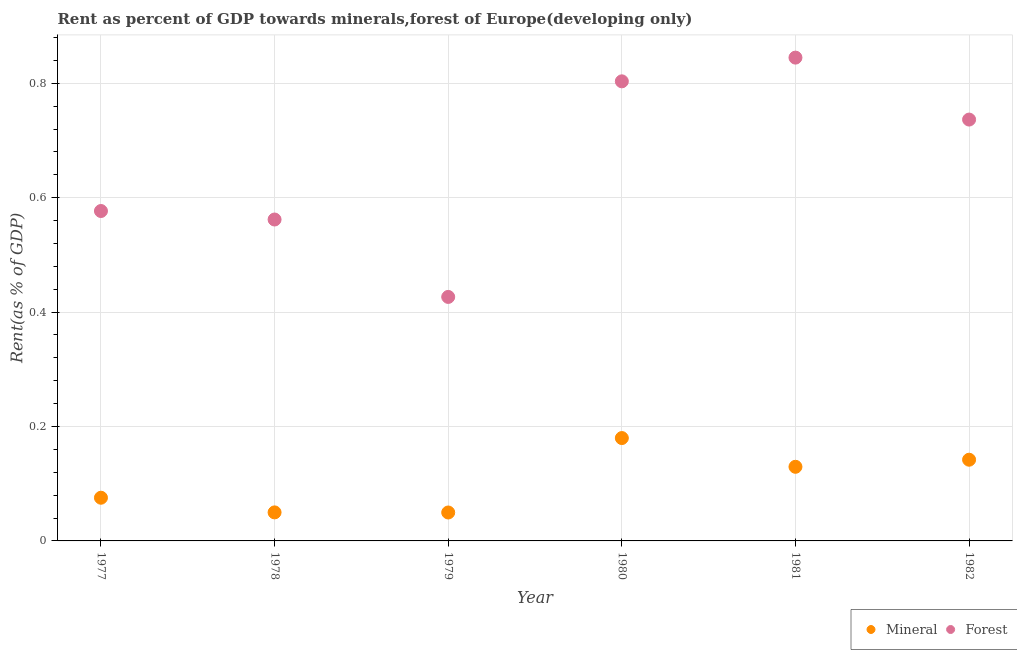What is the mineral rent in 1979?
Ensure brevity in your answer.  0.05. Across all years, what is the maximum forest rent?
Your answer should be very brief. 0.84. Across all years, what is the minimum forest rent?
Your answer should be compact. 0.43. In which year was the mineral rent maximum?
Offer a very short reply. 1980. In which year was the forest rent minimum?
Provide a succinct answer. 1979. What is the total forest rent in the graph?
Offer a very short reply. 3.95. What is the difference between the mineral rent in 1981 and that in 1982?
Your answer should be compact. -0.01. What is the difference between the forest rent in 1981 and the mineral rent in 1978?
Give a very brief answer. 0.79. What is the average mineral rent per year?
Your answer should be compact. 0.1. In the year 1980, what is the difference between the forest rent and mineral rent?
Provide a short and direct response. 0.62. What is the ratio of the mineral rent in 1977 to that in 1980?
Your response must be concise. 0.42. Is the difference between the mineral rent in 1977 and 1978 greater than the difference between the forest rent in 1977 and 1978?
Give a very brief answer. Yes. What is the difference between the highest and the second highest forest rent?
Give a very brief answer. 0.04. What is the difference between the highest and the lowest forest rent?
Provide a short and direct response. 0.42. Does the forest rent monotonically increase over the years?
Make the answer very short. No. Is the forest rent strictly greater than the mineral rent over the years?
Your answer should be compact. Yes. Is the forest rent strictly less than the mineral rent over the years?
Provide a succinct answer. No. How many dotlines are there?
Your answer should be very brief. 2. Does the graph contain any zero values?
Offer a very short reply. No. What is the title of the graph?
Ensure brevity in your answer.  Rent as percent of GDP towards minerals,forest of Europe(developing only). What is the label or title of the X-axis?
Ensure brevity in your answer.  Year. What is the label or title of the Y-axis?
Your answer should be very brief. Rent(as % of GDP). What is the Rent(as % of GDP) of Mineral in 1977?
Your response must be concise. 0.08. What is the Rent(as % of GDP) of Forest in 1977?
Your response must be concise. 0.58. What is the Rent(as % of GDP) of Mineral in 1978?
Your answer should be compact. 0.05. What is the Rent(as % of GDP) in Forest in 1978?
Offer a very short reply. 0.56. What is the Rent(as % of GDP) of Mineral in 1979?
Your answer should be compact. 0.05. What is the Rent(as % of GDP) of Forest in 1979?
Your answer should be very brief. 0.43. What is the Rent(as % of GDP) of Mineral in 1980?
Make the answer very short. 0.18. What is the Rent(as % of GDP) in Forest in 1980?
Your answer should be very brief. 0.8. What is the Rent(as % of GDP) in Mineral in 1981?
Ensure brevity in your answer.  0.13. What is the Rent(as % of GDP) of Forest in 1981?
Offer a terse response. 0.84. What is the Rent(as % of GDP) in Mineral in 1982?
Keep it short and to the point. 0.14. What is the Rent(as % of GDP) of Forest in 1982?
Keep it short and to the point. 0.74. Across all years, what is the maximum Rent(as % of GDP) in Mineral?
Provide a short and direct response. 0.18. Across all years, what is the maximum Rent(as % of GDP) of Forest?
Make the answer very short. 0.84. Across all years, what is the minimum Rent(as % of GDP) in Mineral?
Offer a terse response. 0.05. Across all years, what is the minimum Rent(as % of GDP) of Forest?
Your answer should be very brief. 0.43. What is the total Rent(as % of GDP) in Mineral in the graph?
Give a very brief answer. 0.63. What is the total Rent(as % of GDP) of Forest in the graph?
Offer a very short reply. 3.95. What is the difference between the Rent(as % of GDP) in Mineral in 1977 and that in 1978?
Keep it short and to the point. 0.03. What is the difference between the Rent(as % of GDP) of Forest in 1977 and that in 1978?
Give a very brief answer. 0.01. What is the difference between the Rent(as % of GDP) in Mineral in 1977 and that in 1979?
Provide a succinct answer. 0.03. What is the difference between the Rent(as % of GDP) of Forest in 1977 and that in 1979?
Provide a succinct answer. 0.15. What is the difference between the Rent(as % of GDP) in Mineral in 1977 and that in 1980?
Ensure brevity in your answer.  -0.1. What is the difference between the Rent(as % of GDP) in Forest in 1977 and that in 1980?
Give a very brief answer. -0.23. What is the difference between the Rent(as % of GDP) of Mineral in 1977 and that in 1981?
Your answer should be very brief. -0.05. What is the difference between the Rent(as % of GDP) in Forest in 1977 and that in 1981?
Ensure brevity in your answer.  -0.27. What is the difference between the Rent(as % of GDP) of Mineral in 1977 and that in 1982?
Provide a succinct answer. -0.07. What is the difference between the Rent(as % of GDP) in Forest in 1977 and that in 1982?
Your answer should be compact. -0.16. What is the difference between the Rent(as % of GDP) in Mineral in 1978 and that in 1979?
Make the answer very short. 0. What is the difference between the Rent(as % of GDP) of Forest in 1978 and that in 1979?
Provide a short and direct response. 0.14. What is the difference between the Rent(as % of GDP) in Mineral in 1978 and that in 1980?
Give a very brief answer. -0.13. What is the difference between the Rent(as % of GDP) of Forest in 1978 and that in 1980?
Make the answer very short. -0.24. What is the difference between the Rent(as % of GDP) of Mineral in 1978 and that in 1981?
Provide a succinct answer. -0.08. What is the difference between the Rent(as % of GDP) in Forest in 1978 and that in 1981?
Make the answer very short. -0.28. What is the difference between the Rent(as % of GDP) of Mineral in 1978 and that in 1982?
Provide a short and direct response. -0.09. What is the difference between the Rent(as % of GDP) of Forest in 1978 and that in 1982?
Provide a succinct answer. -0.17. What is the difference between the Rent(as % of GDP) of Mineral in 1979 and that in 1980?
Your response must be concise. -0.13. What is the difference between the Rent(as % of GDP) in Forest in 1979 and that in 1980?
Provide a short and direct response. -0.38. What is the difference between the Rent(as % of GDP) of Mineral in 1979 and that in 1981?
Your answer should be very brief. -0.08. What is the difference between the Rent(as % of GDP) in Forest in 1979 and that in 1981?
Offer a terse response. -0.42. What is the difference between the Rent(as % of GDP) in Mineral in 1979 and that in 1982?
Make the answer very short. -0.09. What is the difference between the Rent(as % of GDP) in Forest in 1979 and that in 1982?
Your response must be concise. -0.31. What is the difference between the Rent(as % of GDP) of Mineral in 1980 and that in 1981?
Offer a terse response. 0.05. What is the difference between the Rent(as % of GDP) of Forest in 1980 and that in 1981?
Ensure brevity in your answer.  -0.04. What is the difference between the Rent(as % of GDP) of Mineral in 1980 and that in 1982?
Provide a succinct answer. 0.04. What is the difference between the Rent(as % of GDP) in Forest in 1980 and that in 1982?
Make the answer very short. 0.07. What is the difference between the Rent(as % of GDP) in Mineral in 1981 and that in 1982?
Give a very brief answer. -0.01. What is the difference between the Rent(as % of GDP) in Forest in 1981 and that in 1982?
Provide a succinct answer. 0.11. What is the difference between the Rent(as % of GDP) of Mineral in 1977 and the Rent(as % of GDP) of Forest in 1978?
Offer a very short reply. -0.49. What is the difference between the Rent(as % of GDP) of Mineral in 1977 and the Rent(as % of GDP) of Forest in 1979?
Your response must be concise. -0.35. What is the difference between the Rent(as % of GDP) in Mineral in 1977 and the Rent(as % of GDP) in Forest in 1980?
Provide a succinct answer. -0.73. What is the difference between the Rent(as % of GDP) in Mineral in 1977 and the Rent(as % of GDP) in Forest in 1981?
Ensure brevity in your answer.  -0.77. What is the difference between the Rent(as % of GDP) of Mineral in 1977 and the Rent(as % of GDP) of Forest in 1982?
Provide a short and direct response. -0.66. What is the difference between the Rent(as % of GDP) in Mineral in 1978 and the Rent(as % of GDP) in Forest in 1979?
Your answer should be compact. -0.38. What is the difference between the Rent(as % of GDP) in Mineral in 1978 and the Rent(as % of GDP) in Forest in 1980?
Keep it short and to the point. -0.75. What is the difference between the Rent(as % of GDP) of Mineral in 1978 and the Rent(as % of GDP) of Forest in 1981?
Provide a succinct answer. -0.79. What is the difference between the Rent(as % of GDP) of Mineral in 1978 and the Rent(as % of GDP) of Forest in 1982?
Offer a terse response. -0.69. What is the difference between the Rent(as % of GDP) in Mineral in 1979 and the Rent(as % of GDP) in Forest in 1980?
Give a very brief answer. -0.75. What is the difference between the Rent(as % of GDP) of Mineral in 1979 and the Rent(as % of GDP) of Forest in 1981?
Keep it short and to the point. -0.8. What is the difference between the Rent(as % of GDP) of Mineral in 1979 and the Rent(as % of GDP) of Forest in 1982?
Give a very brief answer. -0.69. What is the difference between the Rent(as % of GDP) of Mineral in 1980 and the Rent(as % of GDP) of Forest in 1981?
Provide a succinct answer. -0.67. What is the difference between the Rent(as % of GDP) in Mineral in 1980 and the Rent(as % of GDP) in Forest in 1982?
Make the answer very short. -0.56. What is the difference between the Rent(as % of GDP) of Mineral in 1981 and the Rent(as % of GDP) of Forest in 1982?
Offer a very short reply. -0.61. What is the average Rent(as % of GDP) in Mineral per year?
Your response must be concise. 0.1. What is the average Rent(as % of GDP) of Forest per year?
Offer a terse response. 0.66. In the year 1977, what is the difference between the Rent(as % of GDP) in Mineral and Rent(as % of GDP) in Forest?
Give a very brief answer. -0.5. In the year 1978, what is the difference between the Rent(as % of GDP) of Mineral and Rent(as % of GDP) of Forest?
Ensure brevity in your answer.  -0.51. In the year 1979, what is the difference between the Rent(as % of GDP) in Mineral and Rent(as % of GDP) in Forest?
Your answer should be very brief. -0.38. In the year 1980, what is the difference between the Rent(as % of GDP) in Mineral and Rent(as % of GDP) in Forest?
Give a very brief answer. -0.62. In the year 1981, what is the difference between the Rent(as % of GDP) in Mineral and Rent(as % of GDP) in Forest?
Give a very brief answer. -0.72. In the year 1982, what is the difference between the Rent(as % of GDP) in Mineral and Rent(as % of GDP) in Forest?
Your response must be concise. -0.59. What is the ratio of the Rent(as % of GDP) in Mineral in 1977 to that in 1978?
Your answer should be very brief. 1.51. What is the ratio of the Rent(as % of GDP) of Forest in 1977 to that in 1978?
Give a very brief answer. 1.03. What is the ratio of the Rent(as % of GDP) in Mineral in 1977 to that in 1979?
Your answer should be compact. 1.52. What is the ratio of the Rent(as % of GDP) in Forest in 1977 to that in 1979?
Give a very brief answer. 1.35. What is the ratio of the Rent(as % of GDP) of Mineral in 1977 to that in 1980?
Offer a very short reply. 0.42. What is the ratio of the Rent(as % of GDP) of Forest in 1977 to that in 1980?
Give a very brief answer. 0.72. What is the ratio of the Rent(as % of GDP) in Mineral in 1977 to that in 1981?
Keep it short and to the point. 0.58. What is the ratio of the Rent(as % of GDP) in Forest in 1977 to that in 1981?
Provide a short and direct response. 0.68. What is the ratio of the Rent(as % of GDP) in Mineral in 1977 to that in 1982?
Ensure brevity in your answer.  0.53. What is the ratio of the Rent(as % of GDP) of Forest in 1977 to that in 1982?
Your response must be concise. 0.78. What is the ratio of the Rent(as % of GDP) of Mineral in 1978 to that in 1979?
Your answer should be very brief. 1. What is the ratio of the Rent(as % of GDP) of Forest in 1978 to that in 1979?
Your answer should be very brief. 1.32. What is the ratio of the Rent(as % of GDP) in Mineral in 1978 to that in 1980?
Keep it short and to the point. 0.28. What is the ratio of the Rent(as % of GDP) in Forest in 1978 to that in 1980?
Offer a terse response. 0.7. What is the ratio of the Rent(as % of GDP) in Mineral in 1978 to that in 1981?
Ensure brevity in your answer.  0.38. What is the ratio of the Rent(as % of GDP) of Forest in 1978 to that in 1981?
Make the answer very short. 0.67. What is the ratio of the Rent(as % of GDP) of Mineral in 1978 to that in 1982?
Provide a short and direct response. 0.35. What is the ratio of the Rent(as % of GDP) of Forest in 1978 to that in 1982?
Make the answer very short. 0.76. What is the ratio of the Rent(as % of GDP) of Mineral in 1979 to that in 1980?
Your answer should be compact. 0.28. What is the ratio of the Rent(as % of GDP) of Forest in 1979 to that in 1980?
Offer a terse response. 0.53. What is the ratio of the Rent(as % of GDP) in Mineral in 1979 to that in 1981?
Provide a short and direct response. 0.38. What is the ratio of the Rent(as % of GDP) in Forest in 1979 to that in 1981?
Offer a very short reply. 0.5. What is the ratio of the Rent(as % of GDP) in Mineral in 1979 to that in 1982?
Offer a very short reply. 0.35. What is the ratio of the Rent(as % of GDP) in Forest in 1979 to that in 1982?
Offer a terse response. 0.58. What is the ratio of the Rent(as % of GDP) in Mineral in 1980 to that in 1981?
Provide a short and direct response. 1.39. What is the ratio of the Rent(as % of GDP) in Forest in 1980 to that in 1981?
Offer a terse response. 0.95. What is the ratio of the Rent(as % of GDP) in Mineral in 1980 to that in 1982?
Ensure brevity in your answer.  1.27. What is the ratio of the Rent(as % of GDP) in Forest in 1980 to that in 1982?
Ensure brevity in your answer.  1.09. What is the ratio of the Rent(as % of GDP) in Mineral in 1981 to that in 1982?
Offer a very short reply. 0.91. What is the ratio of the Rent(as % of GDP) of Forest in 1981 to that in 1982?
Your answer should be very brief. 1.15. What is the difference between the highest and the second highest Rent(as % of GDP) of Mineral?
Keep it short and to the point. 0.04. What is the difference between the highest and the second highest Rent(as % of GDP) in Forest?
Make the answer very short. 0.04. What is the difference between the highest and the lowest Rent(as % of GDP) in Mineral?
Give a very brief answer. 0.13. What is the difference between the highest and the lowest Rent(as % of GDP) of Forest?
Ensure brevity in your answer.  0.42. 